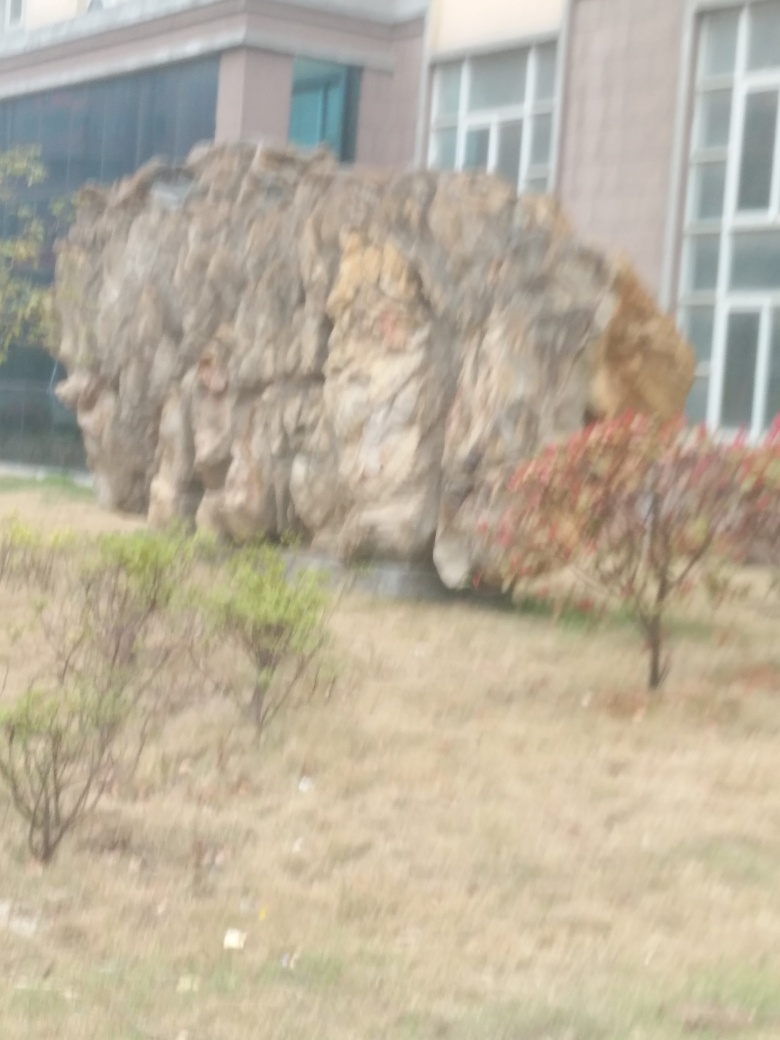What might this location be used for, based on the image? Given the natural and built elements in view, this location could serve as a public outdoor space for relaxation or leisure. The large rock formation could be a focal point for visitors, and the combination of greenery and architecture implies a managed environment possibly within a campus, park, or institutional grounds. 